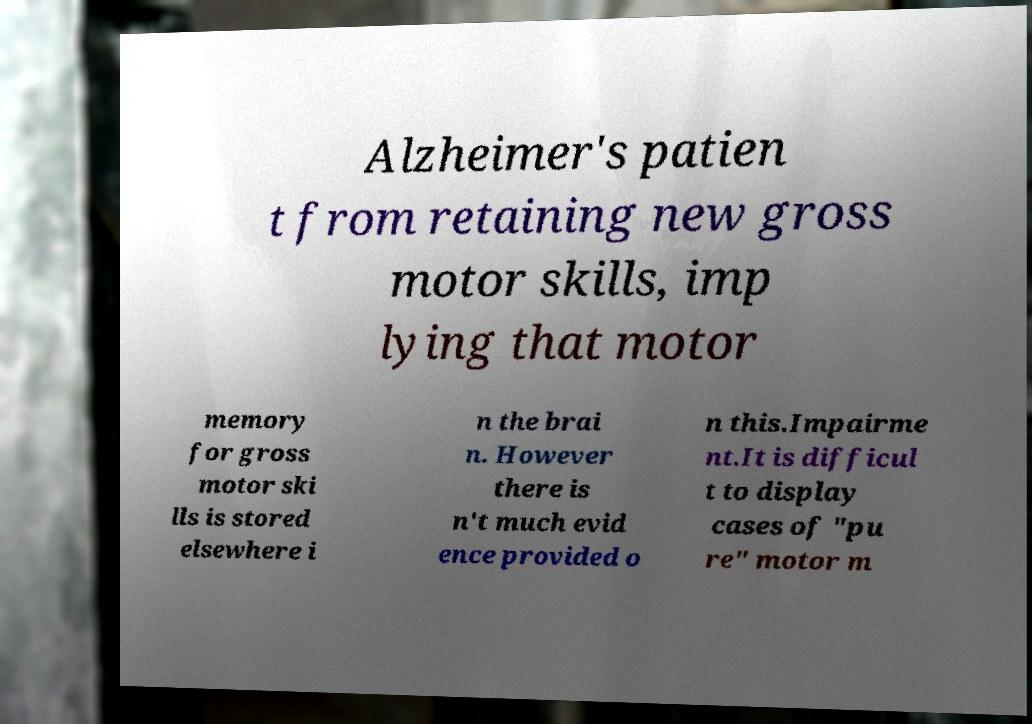For documentation purposes, I need the text within this image transcribed. Could you provide that? Alzheimer's patien t from retaining new gross motor skills, imp lying that motor memory for gross motor ski lls is stored elsewhere i n the brai n. However there is n't much evid ence provided o n this.Impairme nt.It is difficul t to display cases of "pu re" motor m 